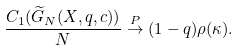Convert formula to latex. <formula><loc_0><loc_0><loc_500><loc_500>\frac { C _ { 1 } ( { \widetilde { G } } _ { N } ( { X } , q , c ) ) } { N } \stackrel { P } { \rightarrow } ( 1 - q ) \rho ( \kappa ) .</formula> 